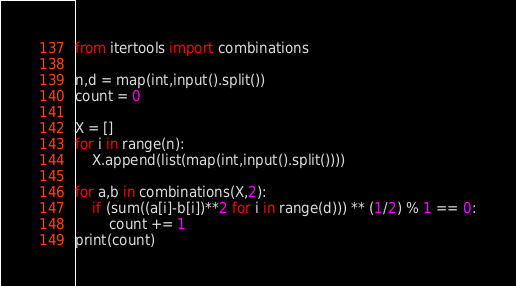<code> <loc_0><loc_0><loc_500><loc_500><_Python_>
from itertools import combinations

n,d = map(int,input().split())
count = 0

X = []
for i in range(n):
    X.append(list(map(int,input().split())))

for a,b in combinations(X,2):
    if (sum((a[i]-b[i])**2 for i in range(d))) ** (1/2) % 1 == 0:
        count += 1
print(count)



</code> 